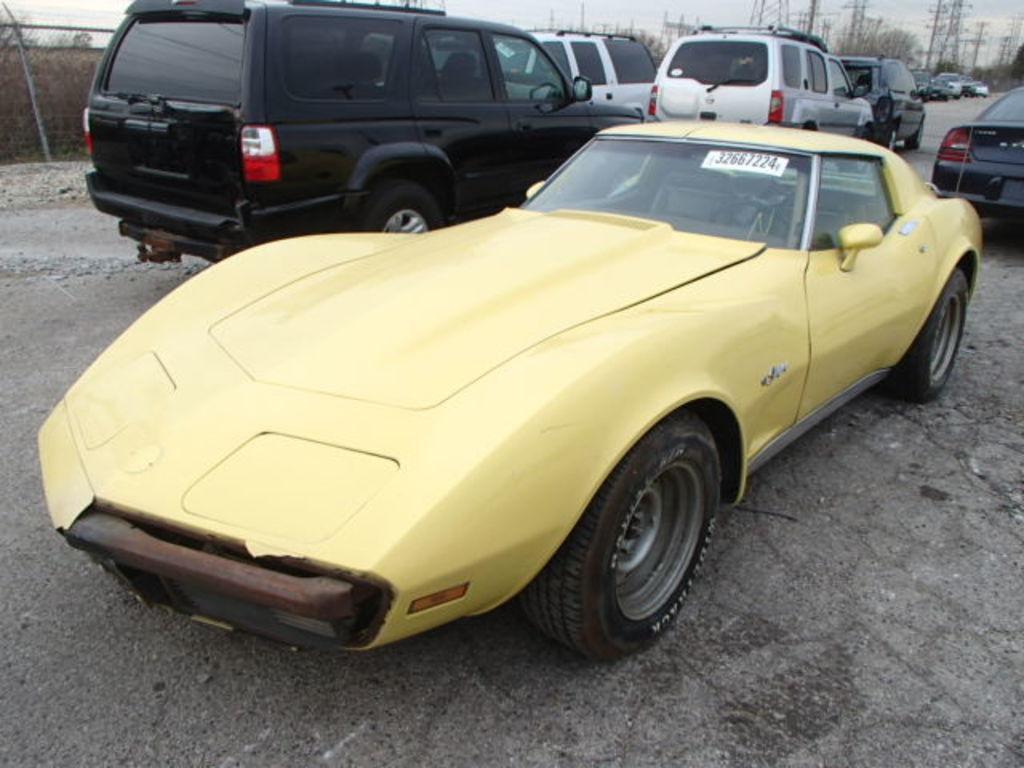How would you summarize this image in a sentence or two? In this image I can see number of vehicles and here I can see few numbers are written. In background I can see the sky and few electric towers. 